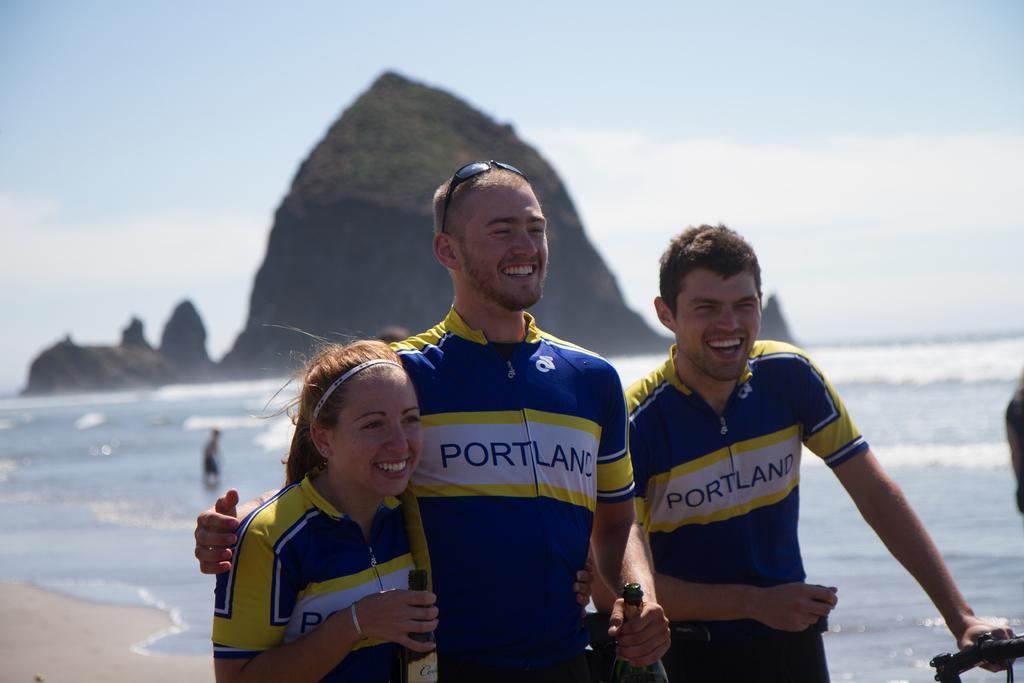<image>
Summarize the visual content of the image. 2 men and a woman smile for a photo while wearing Portland biking jerseys and standing on the beach with a large rock in the background. 